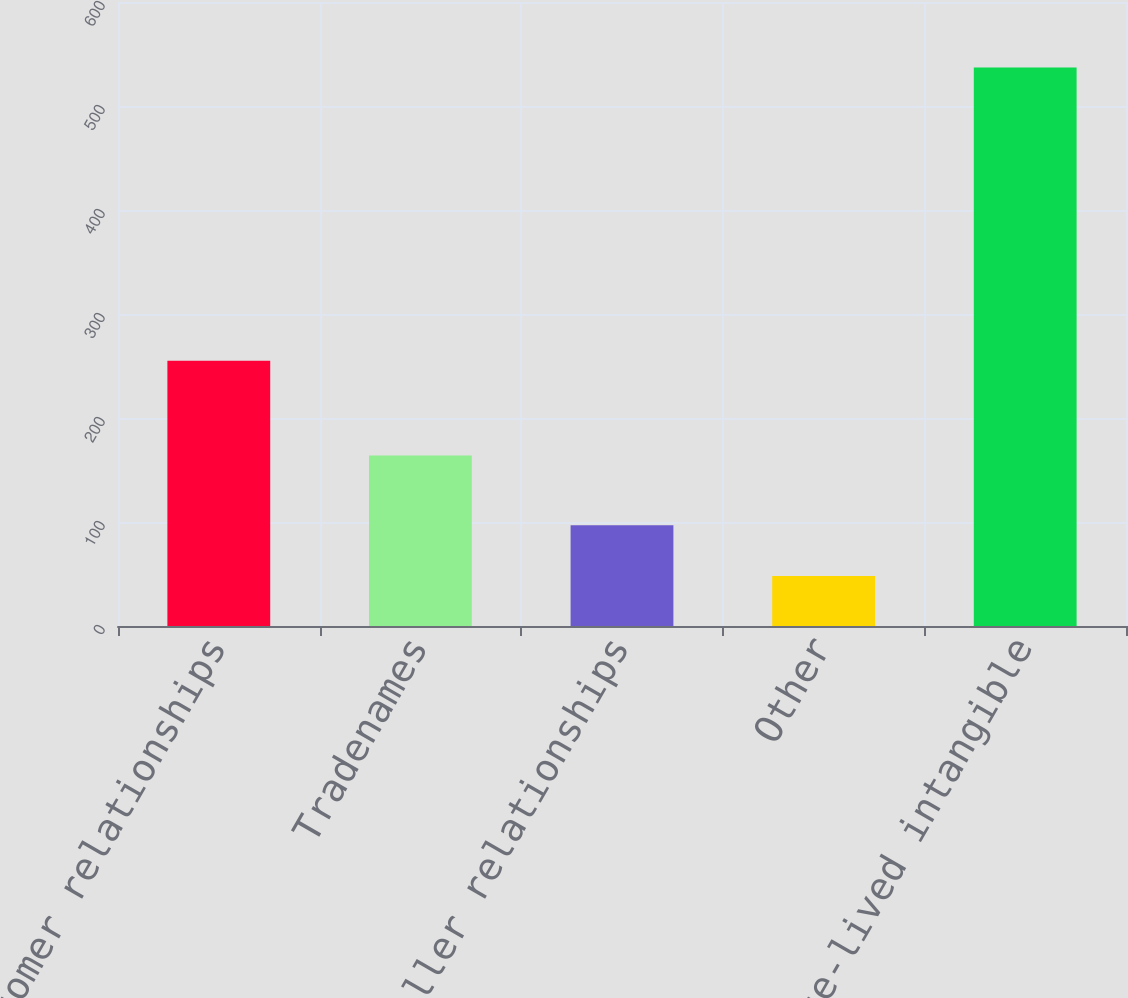Convert chart. <chart><loc_0><loc_0><loc_500><loc_500><bar_chart><fcel>Customer relationships<fcel>Tradenames<fcel>Reseller relationships<fcel>Other<fcel>Total finite-lived intangible<nl><fcel>255<fcel>164<fcel>96.9<fcel>48<fcel>537<nl></chart> 